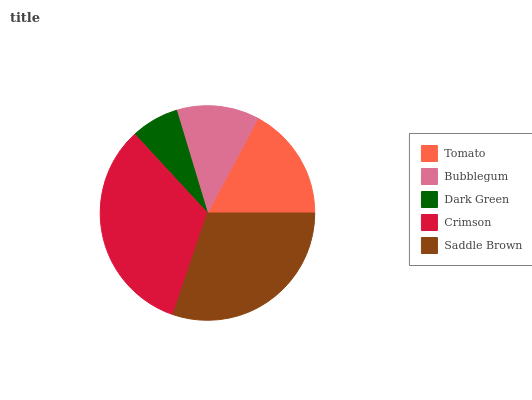Is Dark Green the minimum?
Answer yes or no. Yes. Is Crimson the maximum?
Answer yes or no. Yes. Is Bubblegum the minimum?
Answer yes or no. No. Is Bubblegum the maximum?
Answer yes or no. No. Is Tomato greater than Bubblegum?
Answer yes or no. Yes. Is Bubblegum less than Tomato?
Answer yes or no. Yes. Is Bubblegum greater than Tomato?
Answer yes or no. No. Is Tomato less than Bubblegum?
Answer yes or no. No. Is Tomato the high median?
Answer yes or no. Yes. Is Tomato the low median?
Answer yes or no. Yes. Is Crimson the high median?
Answer yes or no. No. Is Bubblegum the low median?
Answer yes or no. No. 